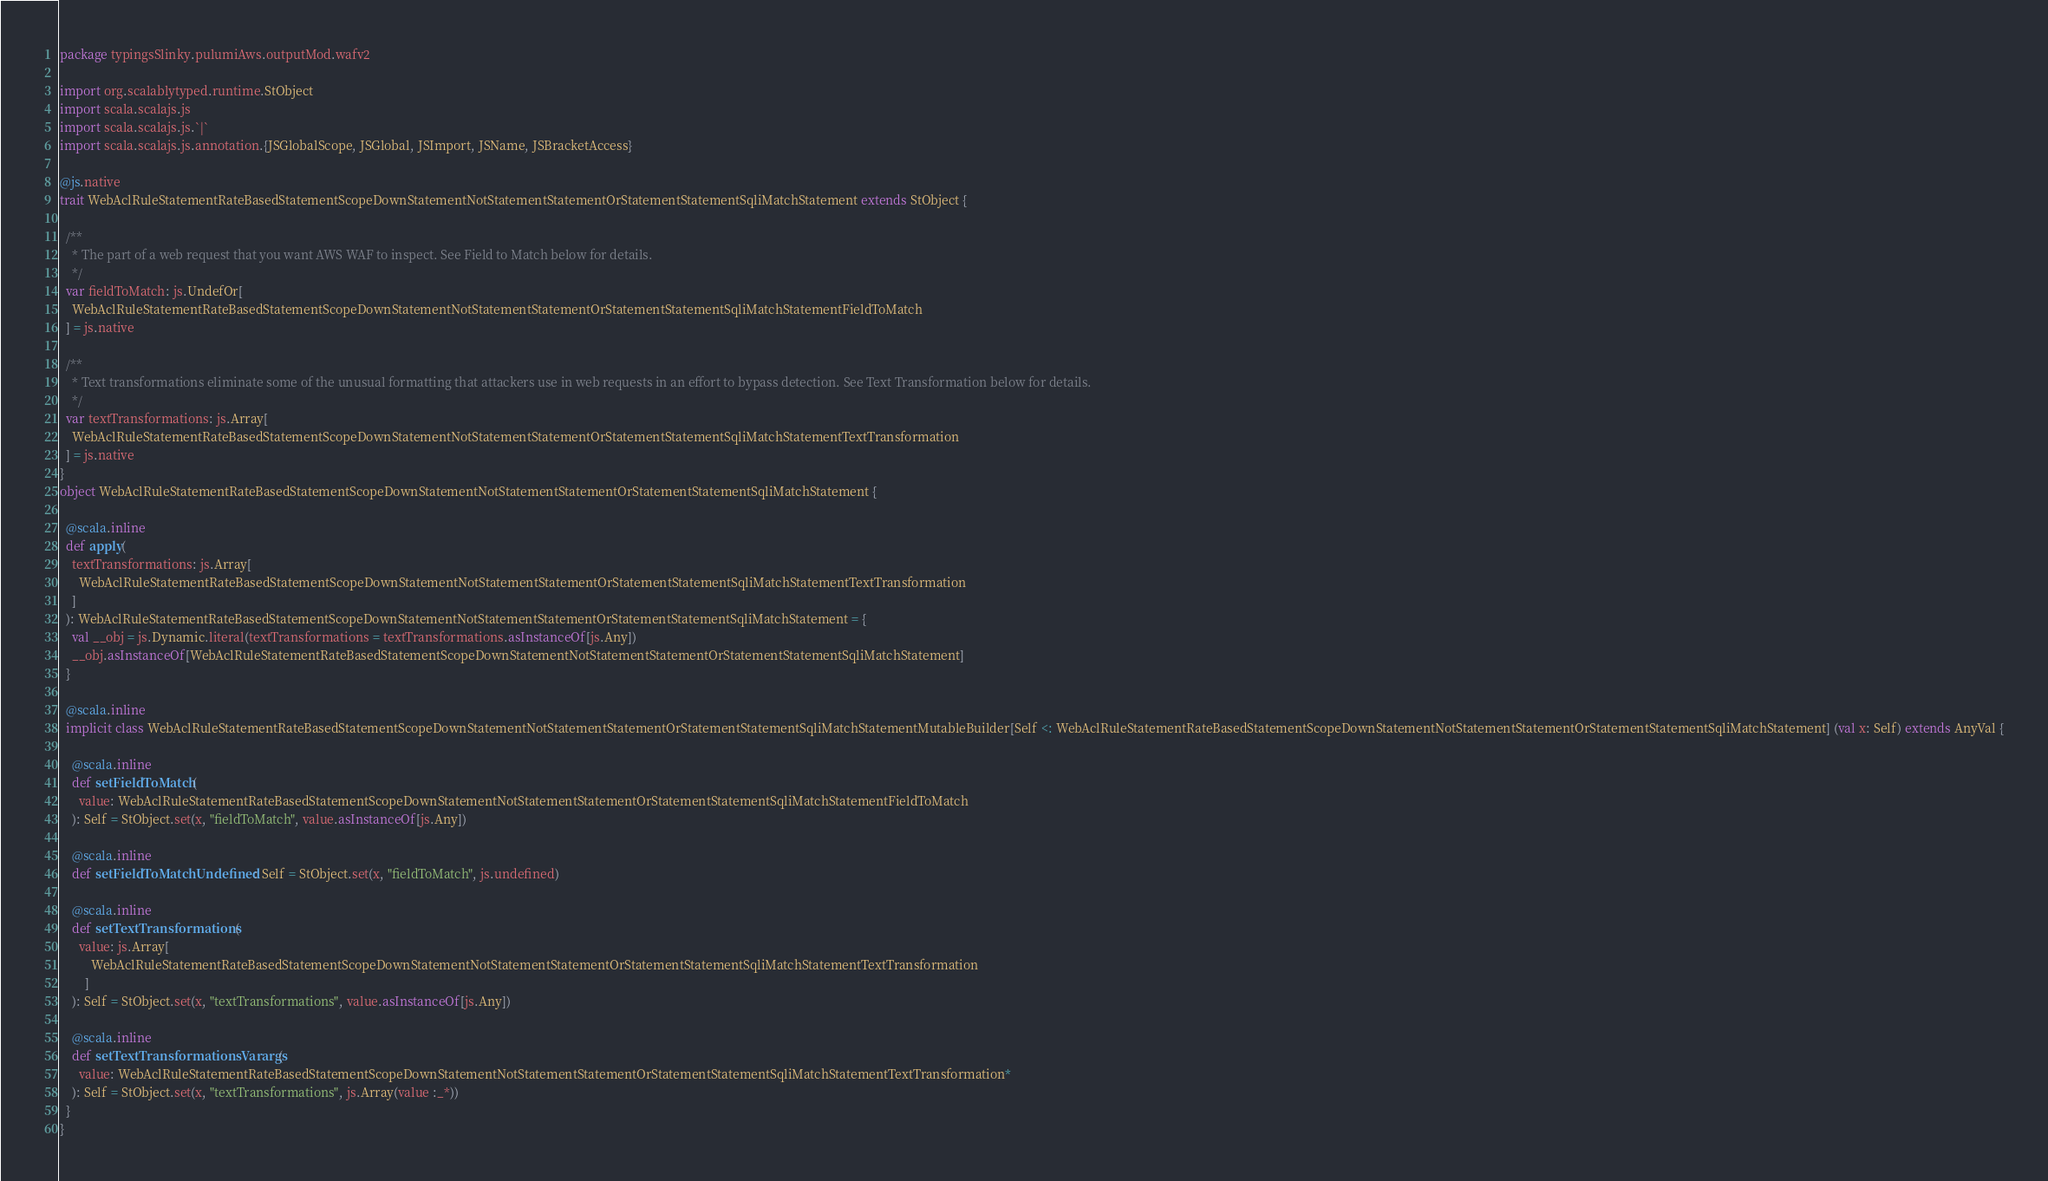Convert code to text. <code><loc_0><loc_0><loc_500><loc_500><_Scala_>package typingsSlinky.pulumiAws.outputMod.wafv2

import org.scalablytyped.runtime.StObject
import scala.scalajs.js
import scala.scalajs.js.`|`
import scala.scalajs.js.annotation.{JSGlobalScope, JSGlobal, JSImport, JSName, JSBracketAccess}

@js.native
trait WebAclRuleStatementRateBasedStatementScopeDownStatementNotStatementStatementOrStatementStatementSqliMatchStatement extends StObject {
  
  /**
    * The part of a web request that you want AWS WAF to inspect. See Field to Match below for details.
    */
  var fieldToMatch: js.UndefOr[
    WebAclRuleStatementRateBasedStatementScopeDownStatementNotStatementStatementOrStatementStatementSqliMatchStatementFieldToMatch
  ] = js.native
  
  /**
    * Text transformations eliminate some of the unusual formatting that attackers use in web requests in an effort to bypass detection. See Text Transformation below for details.
    */
  var textTransformations: js.Array[
    WebAclRuleStatementRateBasedStatementScopeDownStatementNotStatementStatementOrStatementStatementSqliMatchStatementTextTransformation
  ] = js.native
}
object WebAclRuleStatementRateBasedStatementScopeDownStatementNotStatementStatementOrStatementStatementSqliMatchStatement {
  
  @scala.inline
  def apply(
    textTransformations: js.Array[
      WebAclRuleStatementRateBasedStatementScopeDownStatementNotStatementStatementOrStatementStatementSqliMatchStatementTextTransformation
    ]
  ): WebAclRuleStatementRateBasedStatementScopeDownStatementNotStatementStatementOrStatementStatementSqliMatchStatement = {
    val __obj = js.Dynamic.literal(textTransformations = textTransformations.asInstanceOf[js.Any])
    __obj.asInstanceOf[WebAclRuleStatementRateBasedStatementScopeDownStatementNotStatementStatementOrStatementStatementSqliMatchStatement]
  }
  
  @scala.inline
  implicit class WebAclRuleStatementRateBasedStatementScopeDownStatementNotStatementStatementOrStatementStatementSqliMatchStatementMutableBuilder[Self <: WebAclRuleStatementRateBasedStatementScopeDownStatementNotStatementStatementOrStatementStatementSqliMatchStatement] (val x: Self) extends AnyVal {
    
    @scala.inline
    def setFieldToMatch(
      value: WebAclRuleStatementRateBasedStatementScopeDownStatementNotStatementStatementOrStatementStatementSqliMatchStatementFieldToMatch
    ): Self = StObject.set(x, "fieldToMatch", value.asInstanceOf[js.Any])
    
    @scala.inline
    def setFieldToMatchUndefined: Self = StObject.set(x, "fieldToMatch", js.undefined)
    
    @scala.inline
    def setTextTransformations(
      value: js.Array[
          WebAclRuleStatementRateBasedStatementScopeDownStatementNotStatementStatementOrStatementStatementSqliMatchStatementTextTransformation
        ]
    ): Self = StObject.set(x, "textTransformations", value.asInstanceOf[js.Any])
    
    @scala.inline
    def setTextTransformationsVarargs(
      value: WebAclRuleStatementRateBasedStatementScopeDownStatementNotStatementStatementOrStatementStatementSqliMatchStatementTextTransformation*
    ): Self = StObject.set(x, "textTransformations", js.Array(value :_*))
  }
}
</code> 